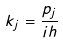<formula> <loc_0><loc_0><loc_500><loc_500>k _ { j } = \frac { p _ { j } } { i h }</formula> 